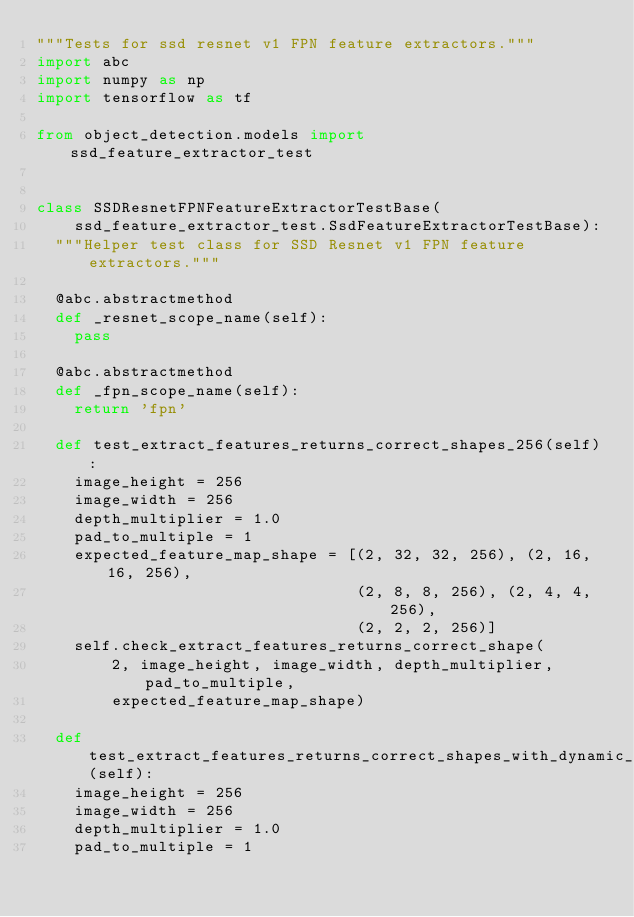<code> <loc_0><loc_0><loc_500><loc_500><_Python_>"""Tests for ssd resnet v1 FPN feature extractors."""
import abc
import numpy as np
import tensorflow as tf

from object_detection.models import ssd_feature_extractor_test


class SSDResnetFPNFeatureExtractorTestBase(
    ssd_feature_extractor_test.SsdFeatureExtractorTestBase):
  """Helper test class for SSD Resnet v1 FPN feature extractors."""

  @abc.abstractmethod
  def _resnet_scope_name(self):
    pass

  @abc.abstractmethod
  def _fpn_scope_name(self):
    return 'fpn'

  def test_extract_features_returns_correct_shapes_256(self):
    image_height = 256
    image_width = 256
    depth_multiplier = 1.0
    pad_to_multiple = 1
    expected_feature_map_shape = [(2, 32, 32, 256), (2, 16, 16, 256),
                                  (2, 8, 8, 256), (2, 4, 4, 256),
                                  (2, 2, 2, 256)]
    self.check_extract_features_returns_correct_shape(
        2, image_height, image_width, depth_multiplier, pad_to_multiple,
        expected_feature_map_shape)

  def test_extract_features_returns_correct_shapes_with_dynamic_inputs(self):
    image_height = 256
    image_width = 256
    depth_multiplier = 1.0
    pad_to_multiple = 1</code> 